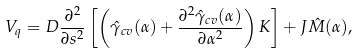<formula> <loc_0><loc_0><loc_500><loc_500>V _ { q } = D \frac { \partial ^ { 2 } } { \partial s ^ { 2 } } \left [ \left ( \hat { \gamma } _ { c v } ( \alpha ) + \frac { \partial ^ { 2 } \hat { \gamma } _ { c v } ( \alpha ) } { \partial \alpha ^ { 2 } } \right ) K \right ] + J \hat { M } ( \alpha ) ,</formula> 